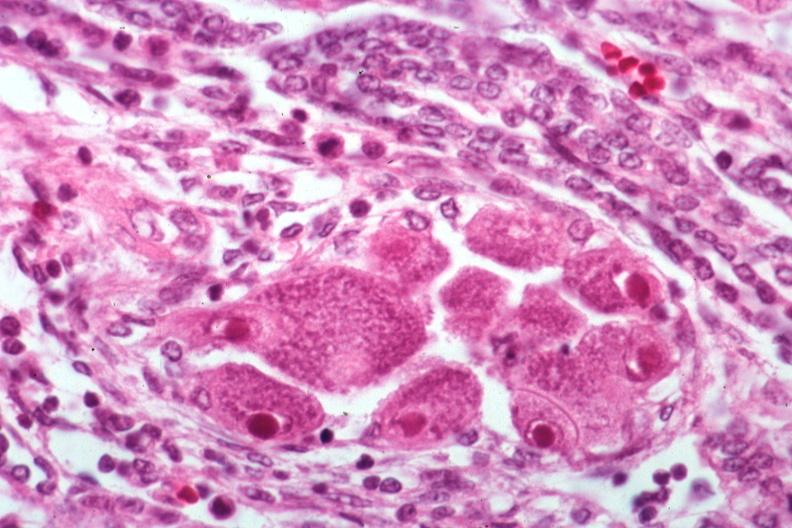s cytomegalovirus present?
Answer the question using a single word or phrase. Yes 